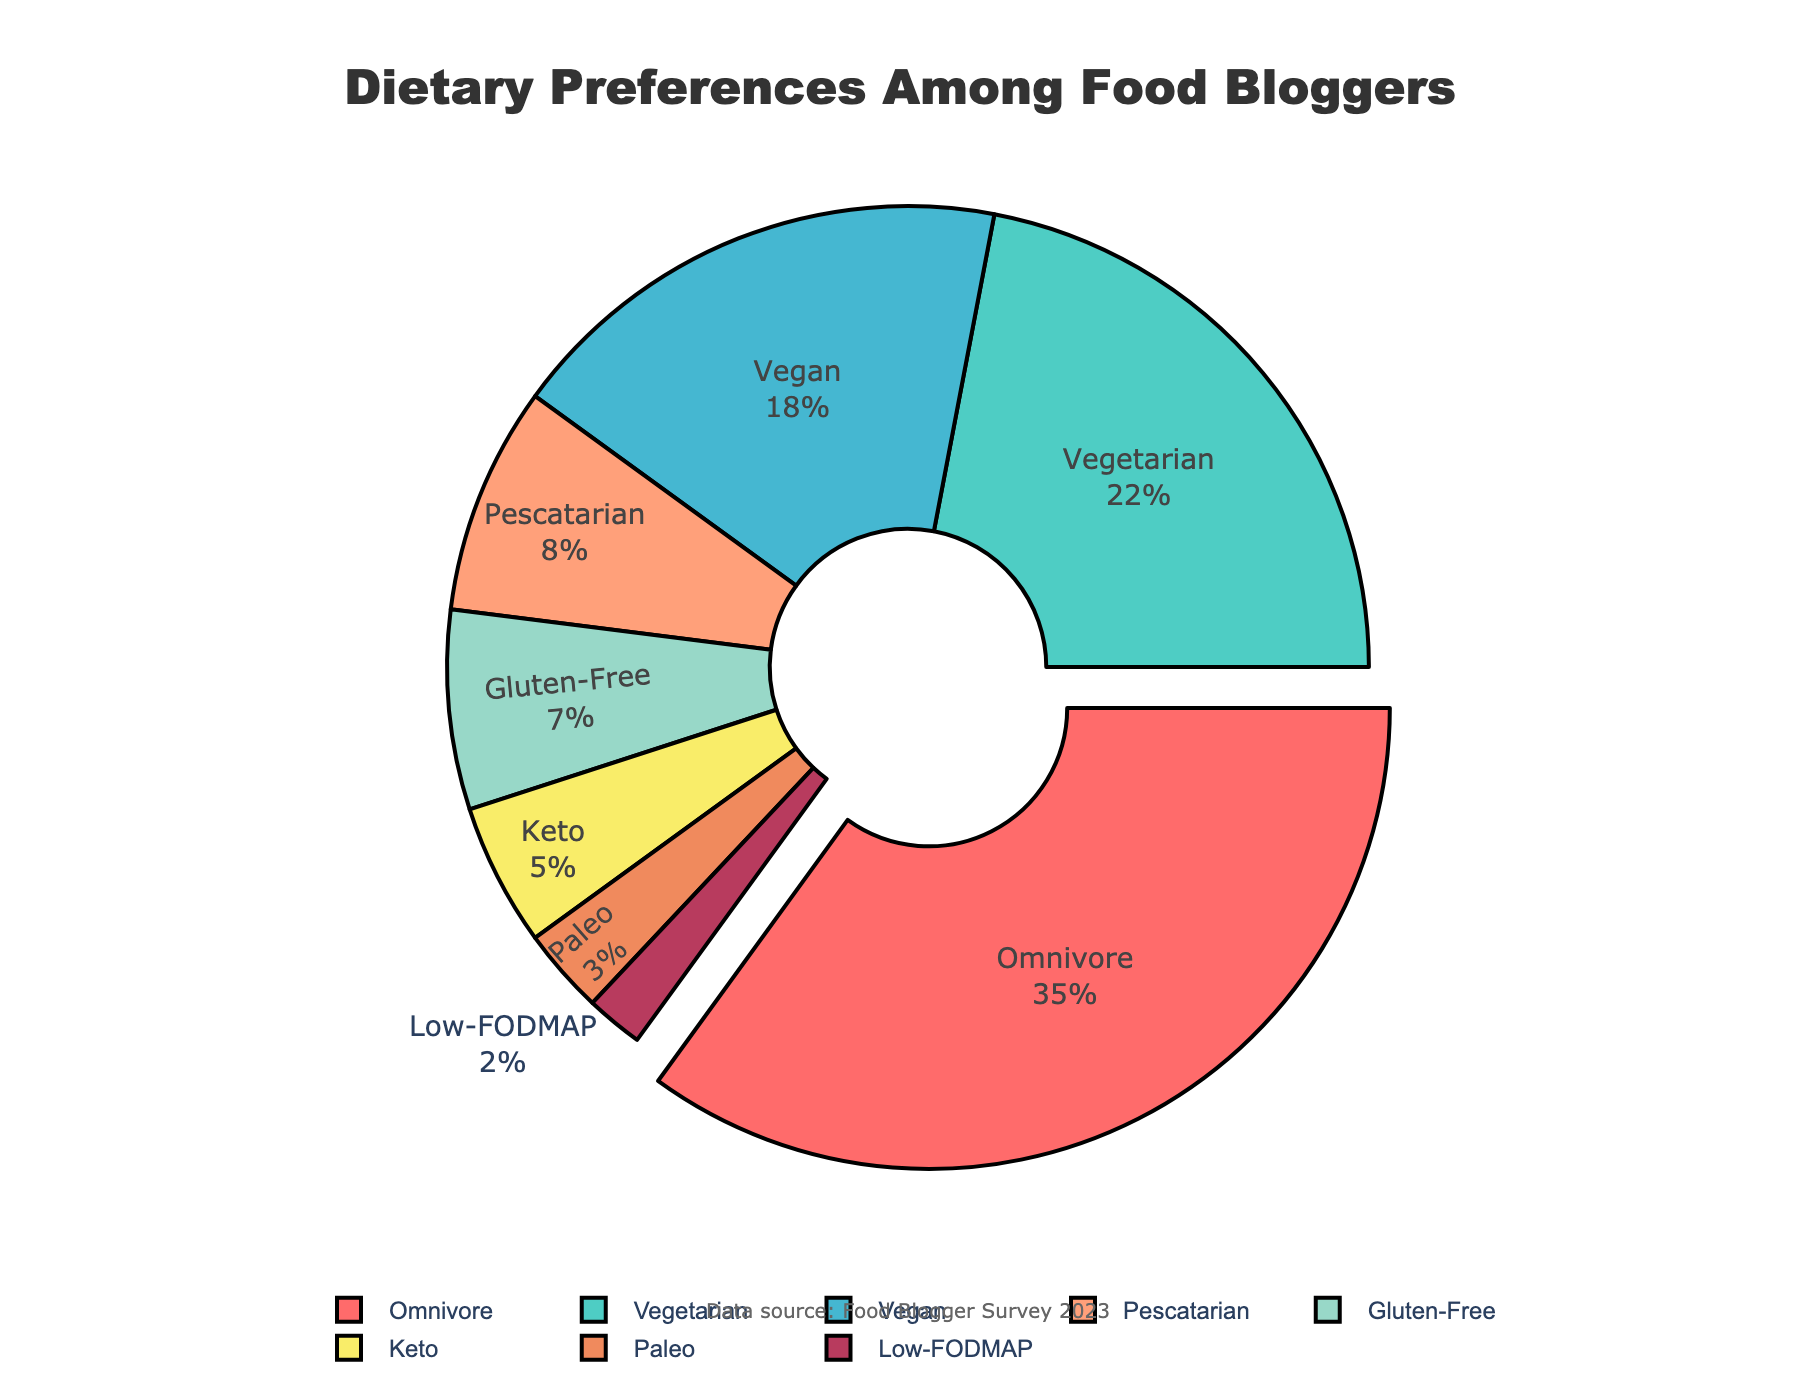What is the dietary preference with the highest proportion among food bloggers? The dietary preference with the highest percentage is highlighted in the pie chart by being slightly pulled out from the rest of the chart. The slice pulled out corresponds to Omnivore with 35%.
Answer: Omnivore Which dietary preference has a larger proportion, Vegetarian or Vegan? By examining the slices of the pie chart, you can see that the Vegetarian slice is larger than the Vegan slice. Vegetarian accounts for 22%, while Vegan accounts for 18%, so Vegetarian has a larger proportion.
Answer: Vegetarian How much larger in percentage is Omnivore compared to Keto? The percentage for Omnivore is 35% and for Keto is 5%. Subtracting the percentage of Keto from Omnivore, 35% - 5% = 30%.
Answer: 30% Sum the percentages of the top three dietary preferences. Adding the percentages of the top three segments: Omnivore (35%), Vegetarian (22%), and Vegan (18%): 35% + 22% + 18% = 75%.
Answer: 75% What is the combined percentage of Gluten-Free and Paleo dietary preferences? The percentage for Gluten-Free is 7% and for Paleo is 3%. Adding these together, 7% + 3% = 10%.
Answer: 10% Which dietary preference is represented by the blue color in the pie chart? Looking at the color assignment to the slices, the blue color corresponds to the Pescatarian dietary preference.
Answer: Pescatarian Compare Omnivore and Low-FODMAP preferences by their proportions. How many times larger is Omnivore compared to Low-FODMAP? The percentage for Omnivore is 35% and for Low-FODMAP is 2%. To find how many times larger Omnivore is, divide 35% by 2%, 35/2 = 17.5.
Answer: 17.5 times What percentage of food bloggers follow a Low-FODMAP diet? The slice labeled Low-FODMAP accounts for 2% of the chart.
Answer: 2% If we combined the percentages of all specialized diets (Vegetarian, Vegan, Pescatarian, Gluten-Free, Keto, Paleo, Low-FODMAP), what would the total percentage be? Adding the percentages for all specialized diets: Vegetarian (22%), Vegan (18%), Pescatarian (8%), Gluten-Free (7%), Keto (5%), Paleo (3%), Low-FODMAP (2%): 22% + 18% + 8% + 7% + 5% + 3% + 2% = 65%.
Answer: 65% 